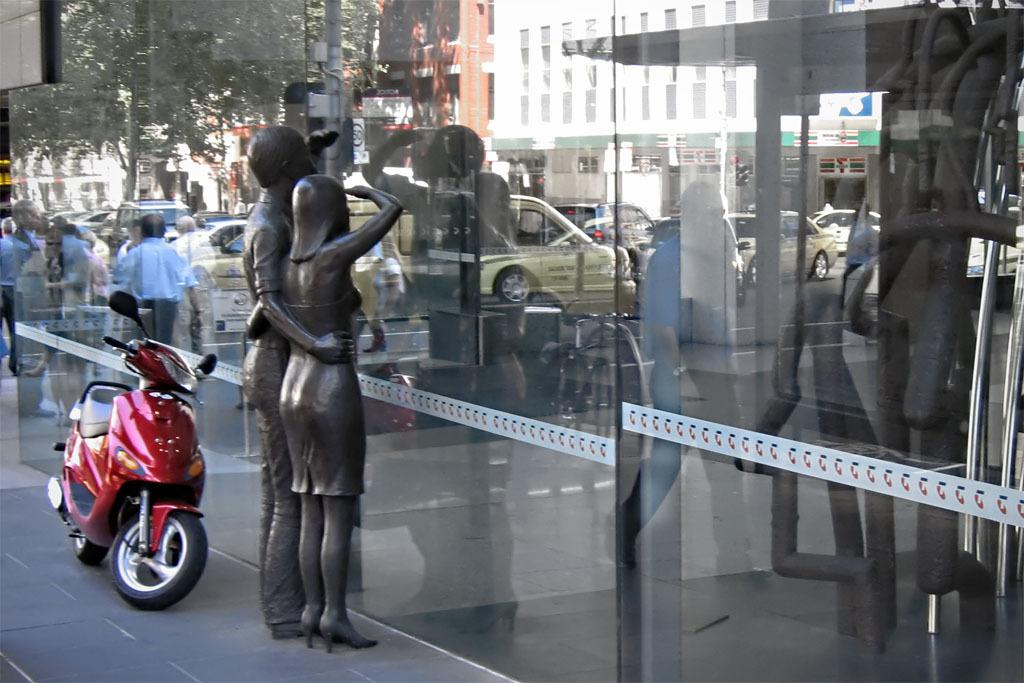What is the main subject in the image? There is a sculpture in the image. Where is the sculpture located in relation to the glass? The sculpture is in front of a glass. What can be seen on the glass in the image? There are reflections of people and vehicles on the glass. What is visible on the left side of the image? There is a vehicle on the left side of the image. What type of shoes can be seen on the animal in the image? There is no animal or shoes present in the image. 